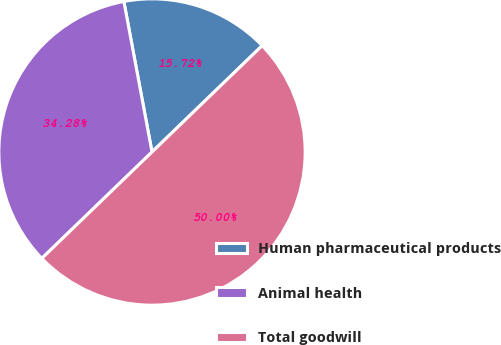Convert chart. <chart><loc_0><loc_0><loc_500><loc_500><pie_chart><fcel>Human pharmaceutical products<fcel>Animal health<fcel>Total goodwill<nl><fcel>15.72%<fcel>34.28%<fcel>50.0%<nl></chart> 